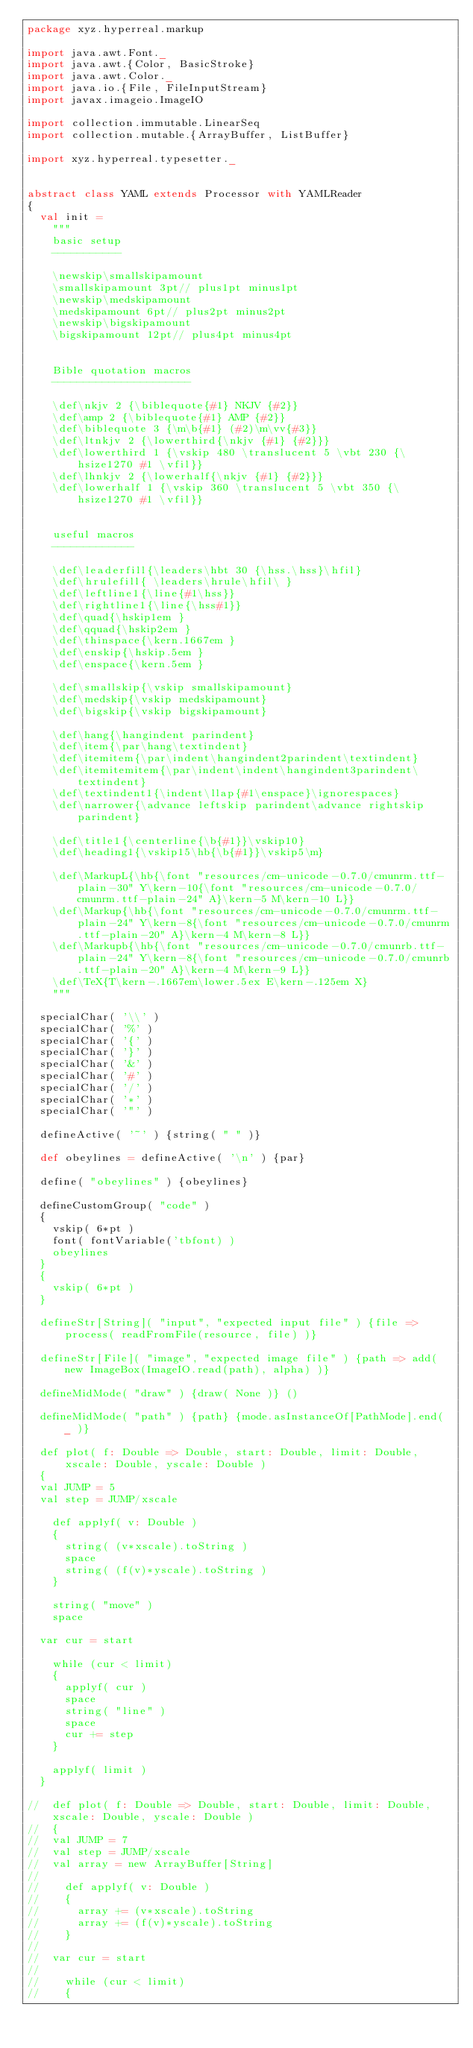<code> <loc_0><loc_0><loc_500><loc_500><_Scala_>package xyz.hyperreal.markup

import java.awt.Font._
import java.awt.{Color, BasicStroke}
import java.awt.Color._
import java.io.{File, FileInputStream}
import javax.imageio.ImageIO

import collection.immutable.LinearSeq
import collection.mutable.{ArrayBuffer, ListBuffer}

import xyz.hyperreal.typesetter._


abstract class YAML extends Processor with YAMLReader
{
	val init =
		"""
		basic setup
		-----------
		
		\newskip\smallskipamount
		\smallskipamount 3pt// plus1pt minus1pt
		\newskip\medskipamount
		\medskipamount 6pt// plus2pt minus2pt
		\newskip\bigskipamount
		\bigskipamount 12pt// plus4pt minus4pt

		
		Bible quotation macros
		----------------------
		
		\def\nkjv 2 {\biblequote{#1} NKJV {#2}}
		\def\amp 2 {\biblequote{#1} AMP {#2}}
		\def\biblequote 3 {\m\b{#1} (#2)\m\vv{#3}}
		\def\ltnkjv 2 {\lowerthird{\nkjv {#1} {#2}}}
		\def\lowerthird 1 {\vskip 480 \translucent 5 \vbt 230 {\hsize1270 #1 \vfil}}
		\def\lhnkjv 2 {\lowerhalf{\nkjv {#1} {#2}}}
		\def\lowerhalf 1 {\vskip 360 \translucent 5 \vbt 350 {\hsize1270 #1 \vfil}}
		
		
		useful macros
		-------------
		
		\def\leaderfill{\leaders\hbt 30 {\hss.\hss}\hfil}
		\def\hrulefill{ \leaders\hrule\hfil\ }
		\def\leftline1{\line{#1\hss}}
		\def\rightline1{\line{\hss#1}}
		\def\quad{\hskip1em }
		\def\qquad{\hskip2em }
		\def\thinspace{\kern.1667em }
		\def\enskip{\hskip.5em }
		\def\enspace{\kern.5em }
		
		\def\smallskip{\vskip smallskipamount}
		\def\medskip{\vskip medskipamount}
		\def\bigskip{\vskip bigskipamount}

		\def\hang{\hangindent parindent}
		\def\item{\par\hang\textindent}
		\def\itemitem{\par\indent\hangindent2parindent\textindent}
		\def\itemitemitem{\par\indent\indent\hangindent3parindent\textindent}
		\def\textindent1{\indent\llap{#1\enspace}\ignorespaces}
		\def\narrower{\advance leftskip parindent\advance rightskip parindent}

		\def\title1{\centerline{\b{#1}}\vskip10}
		\def\heading1{\vskip15\hb{\b{#1}}\vskip5\m}
		
		\def\MarkupL{\hb{\font "resources/cm-unicode-0.7.0/cmunrm.ttf-plain-30" Y\kern-10{\font "resources/cm-unicode-0.7.0/cmunrm.ttf-plain-24" A}\kern-5 M\kern-10 L}}
		\def\Markup{\hb{\font "resources/cm-unicode-0.7.0/cmunrm.ttf-plain-24" Y\kern-8{\font "resources/cm-unicode-0.7.0/cmunrm.ttf-plain-20" A}\kern-4 M\kern-8 L}}
		\def\Markupb{\hb{\font "resources/cm-unicode-0.7.0/cmunrb.ttf-plain-24" Y\kern-8{\font "resources/cm-unicode-0.7.0/cmunrb.ttf-plain-20" A}\kern-4 M\kern-9 L}}
		\def\TeX{T\kern-.1667em\lower.5ex E\kern-.125em X}
		"""

	specialChar( '\\' )
	specialChar( '%' )
	specialChar( '{' )
	specialChar( '}' )
	specialChar( '&' )
	specialChar( '#' )
	specialChar( '/' )
	specialChar( '*' )
	specialChar( '"' )
	
	defineActive( '~' ) {string( " " )}

	def obeylines = defineActive( '\n' ) {par}
	
	define( "obeylines" ) {obeylines}
	
	defineCustomGroup( "code" )
	{
		vskip( 6*pt )
		font( fontVariable('tbfont) )
		obeylines
	}
	{
		vskip( 6*pt )
	}
	
	defineStr[String]( "input", "expected input file" ) {file => process( readFromFile(resource, file) )}
	
	defineStr[File]( "image", "expected image file" ) {path => add( new ImageBox(ImageIO.read(path), alpha) )}
	
	defineMidMode( "draw" ) {draw( None )} ()
	
	defineMidMode( "path" ) {path} {mode.asInstanceOf[PathMode].end( _ )}
	
	def plot( f: Double => Double, start: Double, limit: Double, xscale: Double, yscale: Double )
	{
	val JUMP = 5
	val step = JUMP/xscale
		
		def applyf( v: Double )
		{
			string( (v*xscale).toString )
			space
			string( (f(v)*yscale).toString )
		}
		
		string( "move" )
		space
		
	var cur = start
	
		while (cur < limit)
		{
			applyf( cur )
			space
			string( "line" )
			space
			cur += step
		}
		
		applyf( limit )
	}
	
//	def plot( f: Double => Double, start: Double, limit: Double, xscale: Double, yscale: Double )
//	{
//	val JUMP = 7
//	val step = JUMP/xscale
//	val array = new ArrayBuffer[String]
//	
//		def applyf( v: Double )
//		{
//			array += (v*xscale).toString
//			array += (f(v)*yscale).toString
//		}
//		
//	var cur = start
//	
//		while (cur < limit)
//		{</code> 